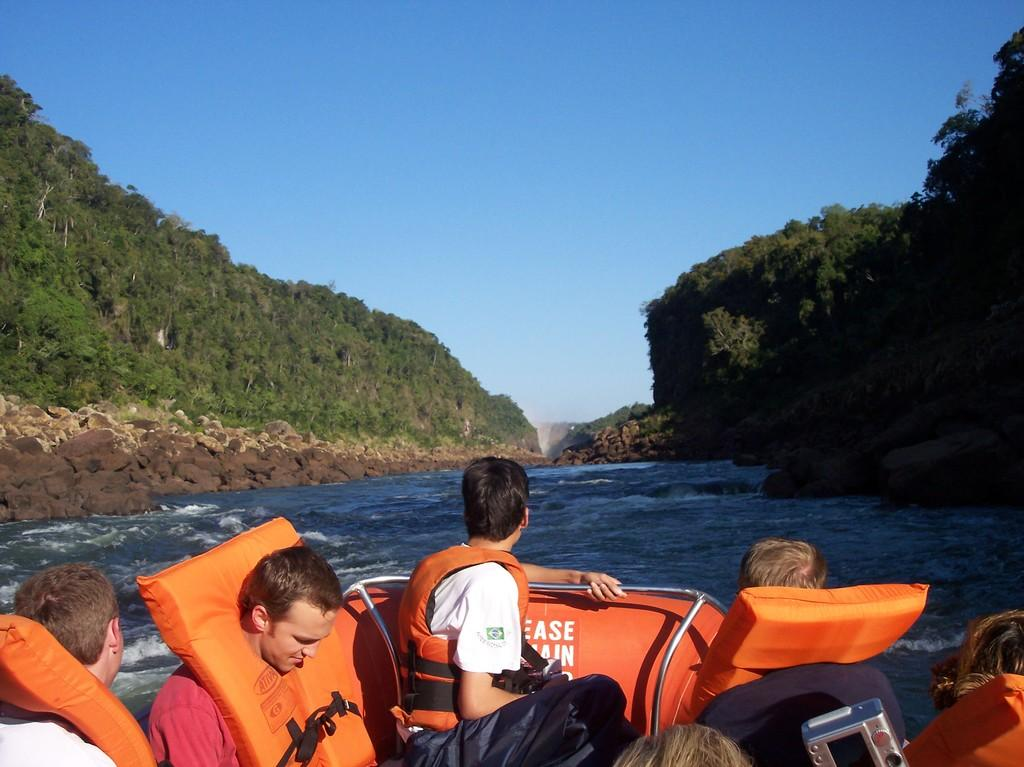What are the people in the image doing? The persons in the image are sitting on a surf boat. What can be seen in the background of the image? There are mountains in the background of the image. What is the primary setting of the image? The image is set in a location with water visible. What type of mint is growing on the mountains in the image? There is no mint visible in the image, as the focus is on the people sitting on the surf boat and the mountains in the background. 